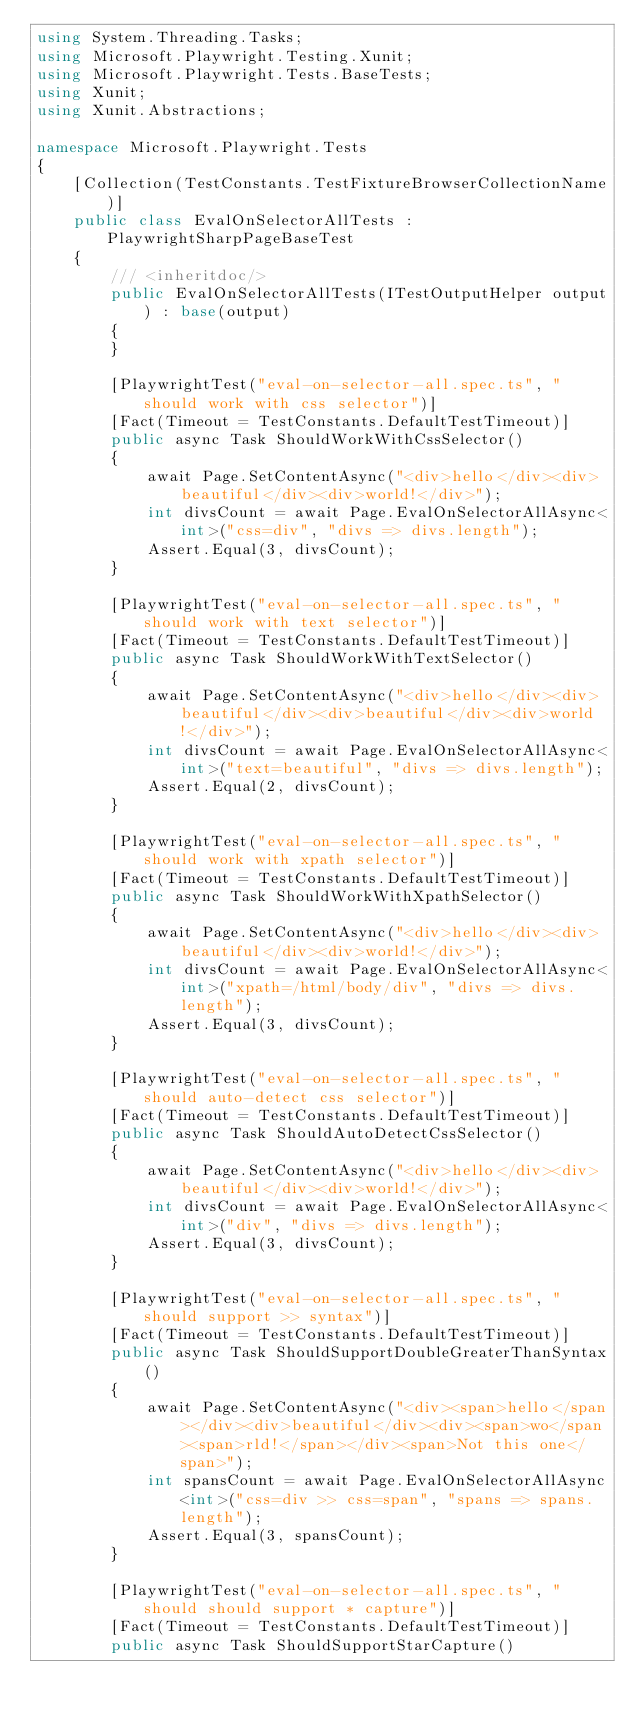Convert code to text. <code><loc_0><loc_0><loc_500><loc_500><_C#_>using System.Threading.Tasks;
using Microsoft.Playwright.Testing.Xunit;
using Microsoft.Playwright.Tests.BaseTests;
using Xunit;
using Xunit.Abstractions;

namespace Microsoft.Playwright.Tests
{
    [Collection(TestConstants.TestFixtureBrowserCollectionName)]
    public class EvalOnSelectorAllTests : PlaywrightSharpPageBaseTest
    {
        /// <inheritdoc/>
        public EvalOnSelectorAllTests(ITestOutputHelper output) : base(output)
        {
        }

        [PlaywrightTest("eval-on-selector-all.spec.ts", "should work with css selector")]
        [Fact(Timeout = TestConstants.DefaultTestTimeout)]
        public async Task ShouldWorkWithCssSelector()
        {
            await Page.SetContentAsync("<div>hello</div><div>beautiful</div><div>world!</div>");
            int divsCount = await Page.EvalOnSelectorAllAsync<int>("css=div", "divs => divs.length");
            Assert.Equal(3, divsCount);
        }

        [PlaywrightTest("eval-on-selector-all.spec.ts", "should work with text selector")]
        [Fact(Timeout = TestConstants.DefaultTestTimeout)]
        public async Task ShouldWorkWithTextSelector()
        {
            await Page.SetContentAsync("<div>hello</div><div>beautiful</div><div>beautiful</div><div>world!</div>");
            int divsCount = await Page.EvalOnSelectorAllAsync<int>("text=beautiful", "divs => divs.length");
            Assert.Equal(2, divsCount);
        }

        [PlaywrightTest("eval-on-selector-all.spec.ts", "should work with xpath selector")]
        [Fact(Timeout = TestConstants.DefaultTestTimeout)]
        public async Task ShouldWorkWithXpathSelector()
        {
            await Page.SetContentAsync("<div>hello</div><div>beautiful</div><div>world!</div>");
            int divsCount = await Page.EvalOnSelectorAllAsync<int>("xpath=/html/body/div", "divs => divs.length");
            Assert.Equal(3, divsCount);
        }

        [PlaywrightTest("eval-on-selector-all.spec.ts", "should auto-detect css selector")]
        [Fact(Timeout = TestConstants.DefaultTestTimeout)]
        public async Task ShouldAutoDetectCssSelector()
        {
            await Page.SetContentAsync("<div>hello</div><div>beautiful</div><div>world!</div>");
            int divsCount = await Page.EvalOnSelectorAllAsync<int>("div", "divs => divs.length");
            Assert.Equal(3, divsCount);
        }

        [PlaywrightTest("eval-on-selector-all.spec.ts", "should support >> syntax")]
        [Fact(Timeout = TestConstants.DefaultTestTimeout)]
        public async Task ShouldSupportDoubleGreaterThanSyntax()
        {
            await Page.SetContentAsync("<div><span>hello</span></div><div>beautiful</div><div><span>wo</span><span>rld!</span></div><span>Not this one</span>");
            int spansCount = await Page.EvalOnSelectorAllAsync<int>("css=div >> css=span", "spans => spans.length");
            Assert.Equal(3, spansCount);
        }

        [PlaywrightTest("eval-on-selector-all.spec.ts", "should should support * capture")]
        [Fact(Timeout = TestConstants.DefaultTestTimeout)]
        public async Task ShouldSupportStarCapture()</code> 